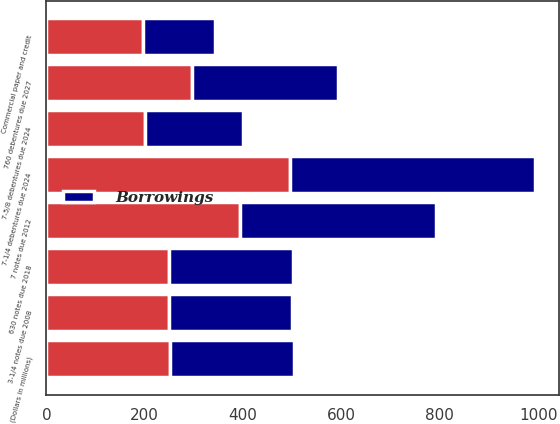Convert chart to OTSL. <chart><loc_0><loc_0><loc_500><loc_500><stacked_bar_chart><ecel><fcel>(Dollars in millions)<fcel>3-1/4 notes due 2008<fcel>630 notes due 2018<fcel>7 notes due 2012<fcel>7-1/4 debentures due 2024<fcel>7-5/8 debentures due 2024<fcel>760 debentures due 2027<fcel>Commercial paper and credit<nl><fcel>Borrowings<fcel>251.5<fcel>250<fcel>253<fcel>399<fcel>497<fcel>200<fcel>297<fcel>146<nl><fcel>nan<fcel>251.5<fcel>250<fcel>249<fcel>394<fcel>496<fcel>200<fcel>297<fcel>196<nl></chart> 